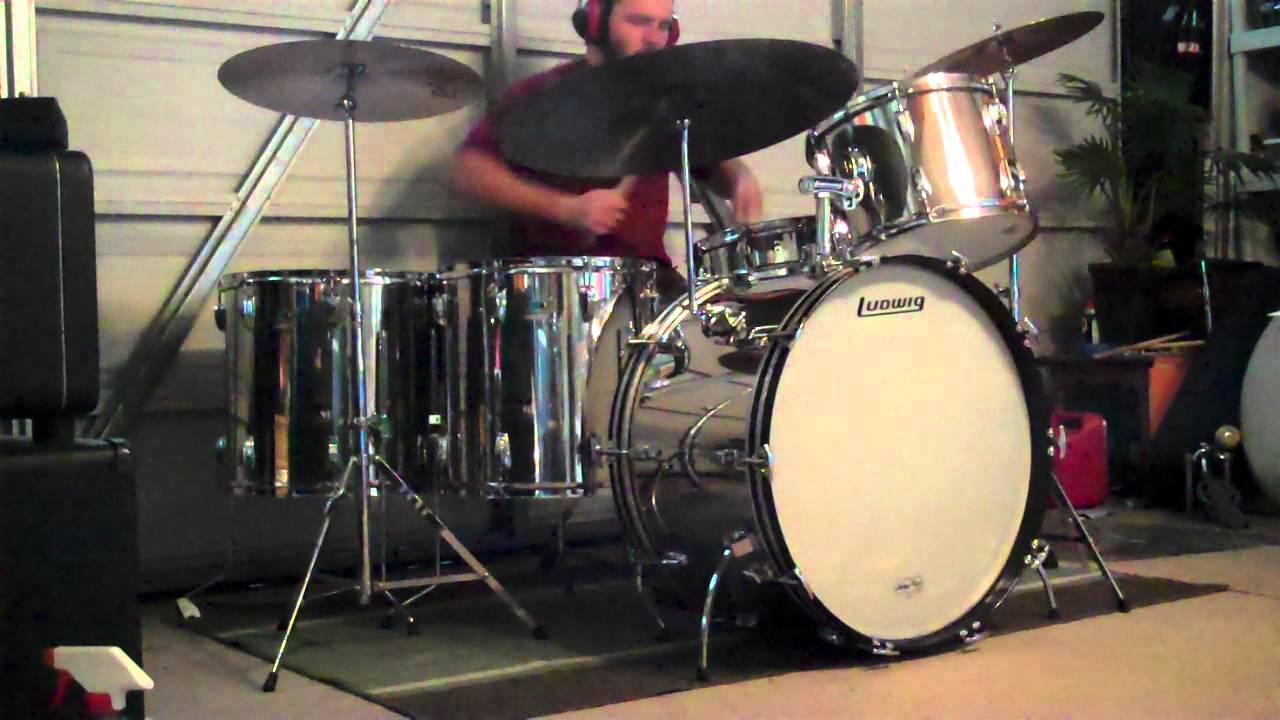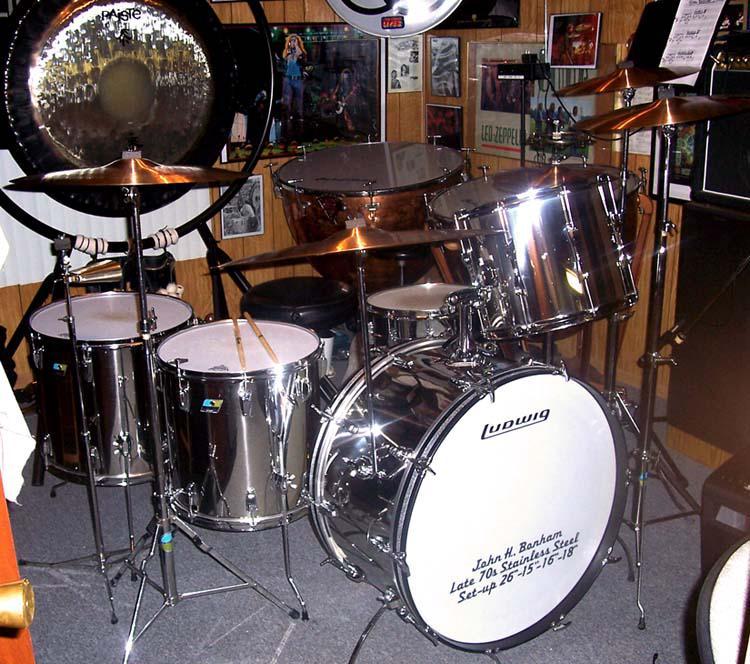The first image is the image on the left, the second image is the image on the right. Considering the images on both sides, is "The face of the large drum in the front is entirely visible in each image." valid? Answer yes or no. Yes. The first image is the image on the left, the second image is the image on the right. Analyze the images presented: Is the assertion "In at least one image there is a man playing a sliver drum set that is facing forward right." valid? Answer yes or no. Yes. 